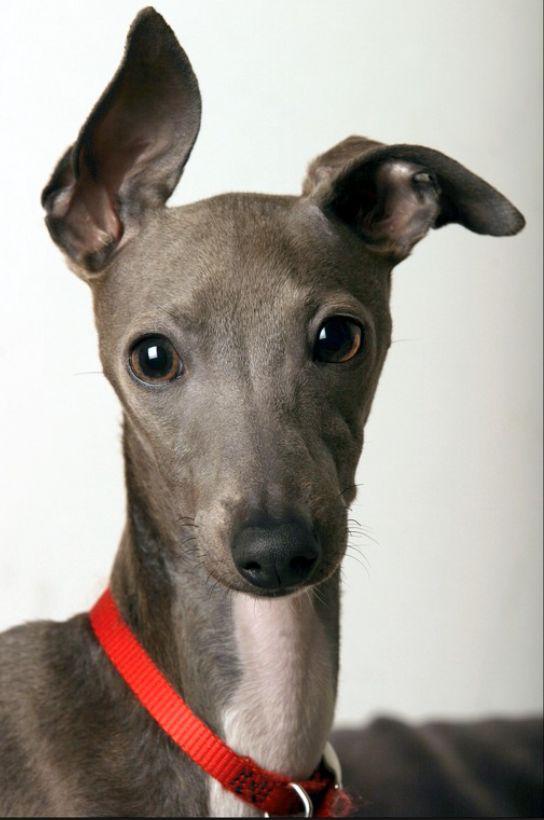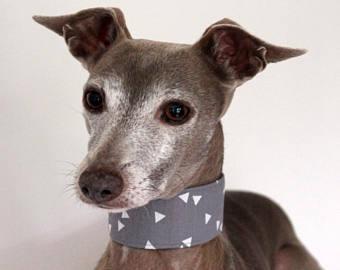The first image is the image on the left, the second image is the image on the right. For the images shown, is this caption "One of the dogs has a pink collar." true? Answer yes or no. No. 